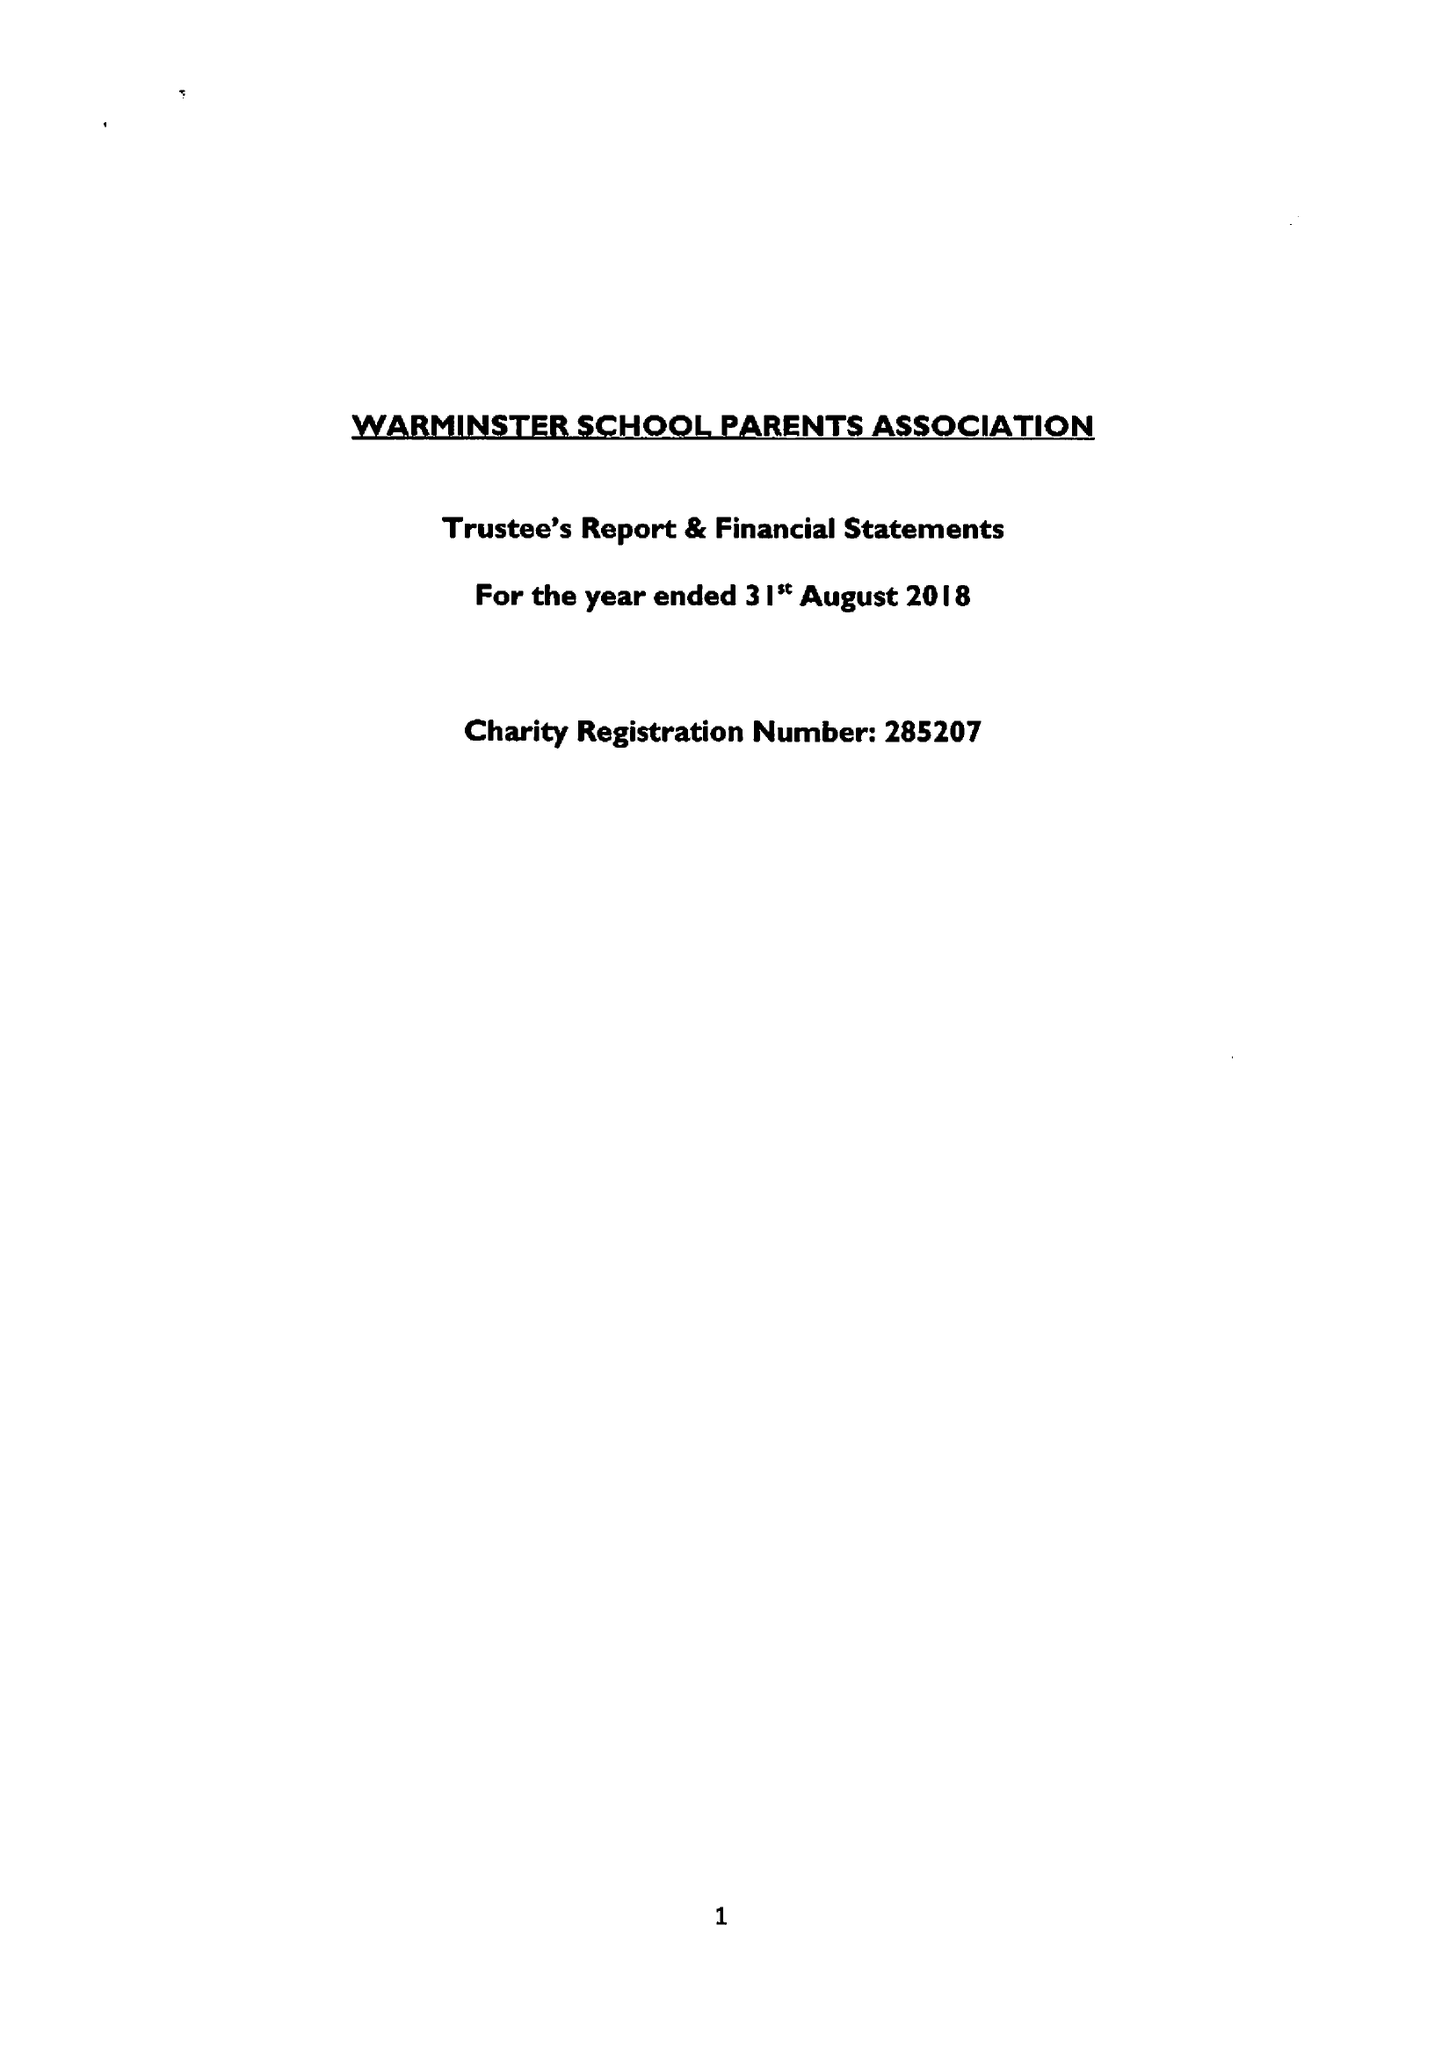What is the value for the address__street_line?
Answer the question using a single word or phrase. CHURCH STREET 